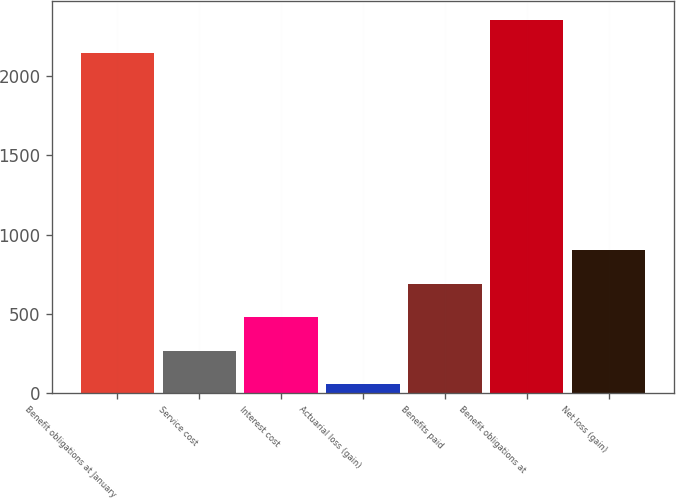Convert chart to OTSL. <chart><loc_0><loc_0><loc_500><loc_500><bar_chart><fcel>Benefit obligations at January<fcel>Service cost<fcel>Interest cost<fcel>Actuarial loss (gain)<fcel>Benefits paid<fcel>Benefit obligations at<fcel>Net loss (gain)<nl><fcel>2143<fcel>268.6<fcel>479.2<fcel>58<fcel>689.8<fcel>2353.6<fcel>900.4<nl></chart> 